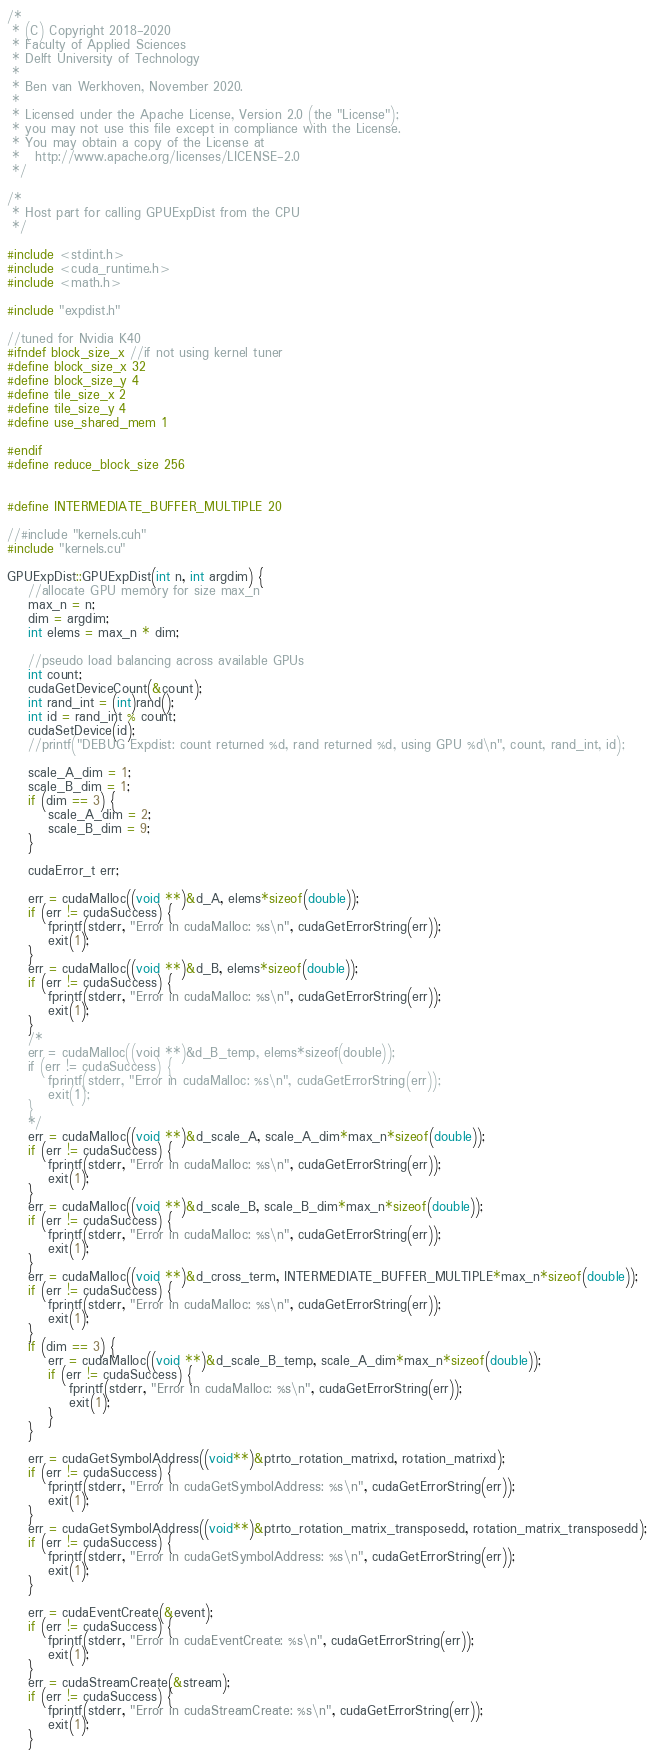Convert code to text. <code><loc_0><loc_0><loc_500><loc_500><_Cuda_>/*
 * (C) Copyright 2018-2020      
 * Faculty of Applied Sciences
 * Delft University of Technology
 *
 * Ben van Werkhoven, November 2020.
 *
 * Licensed under the Apache License, Version 2.0 (the "License");
 * you may not use this file except in compliance with the License.
 * You may obtain a copy of the License at
 *   http://www.apache.org/licenses/LICENSE-2.0
 */
        
/*
 * Host part for calling GPUExpDist from the CPU 
 */

#include <stdint.h>
#include <cuda_runtime.h>
#include <math.h>

#include "expdist.h"

//tuned for Nvidia K40
#ifndef block_size_x //if not using kernel tuner
#define block_size_x 32
#define block_size_y 4
#define tile_size_x 2
#define tile_size_y 4
#define use_shared_mem 1

#endif
#define reduce_block_size 256


#define INTERMEDIATE_BUFFER_MULTIPLE 20

//#include "kernels.cuh"
#include "kernels.cu"

GPUExpDist::GPUExpDist(int n, int argdim) {
    //allocate GPU memory for size max_n
    max_n = n;
    dim = argdim;
    int elems = max_n * dim;

    //pseudo load balancing across available GPUs
    int count;
    cudaGetDeviceCount(&count);
    int rand_int = (int)rand();
    int id = rand_int % count;
    cudaSetDevice(id);
    //printf("DEBUG Expdist: count returned %d, rand returned %d, using GPU %d\n", count, rand_int, id);

    scale_A_dim = 1;
    scale_B_dim = 1;
    if (dim == 3) {
        scale_A_dim = 2;
        scale_B_dim = 9;
    }

    cudaError_t err;

    err = cudaMalloc((void **)&d_A, elems*sizeof(double));
    if (err != cudaSuccess) {
        fprintf(stderr, "Error in cudaMalloc: %s\n", cudaGetErrorString(err));
        exit(1);
    }
    err = cudaMalloc((void **)&d_B, elems*sizeof(double));
    if (err != cudaSuccess) {
        fprintf(stderr, "Error in cudaMalloc: %s\n", cudaGetErrorString(err));
        exit(1);
    }
    /*
    err = cudaMalloc((void **)&d_B_temp, elems*sizeof(double));
    if (err != cudaSuccess) {
        fprintf(stderr, "Error in cudaMalloc: %s\n", cudaGetErrorString(err));
        exit(1);
    }
    */
    err = cudaMalloc((void **)&d_scale_A, scale_A_dim*max_n*sizeof(double));
    if (err != cudaSuccess) {
        fprintf(stderr, "Error in cudaMalloc: %s\n", cudaGetErrorString(err));
        exit(1);
    }
    err = cudaMalloc((void **)&d_scale_B, scale_B_dim*max_n*sizeof(double));
    if (err != cudaSuccess) {
        fprintf(stderr, "Error in cudaMalloc: %s\n", cudaGetErrorString(err));
        exit(1);
    }
    err = cudaMalloc((void **)&d_cross_term, INTERMEDIATE_BUFFER_MULTIPLE*max_n*sizeof(double));
    if (err != cudaSuccess) {
        fprintf(stderr, "Error in cudaMalloc: %s\n", cudaGetErrorString(err));
        exit(1);
    }
    if (dim == 3) {
        err = cudaMalloc((void **)&d_scale_B_temp, scale_A_dim*max_n*sizeof(double));
        if (err != cudaSuccess) {
            fprintf(stderr, "Error in cudaMalloc: %s\n", cudaGetErrorString(err));
            exit(1);
        }
    }

    err = cudaGetSymbolAddress((void**)&ptrto_rotation_matrixd, rotation_matrixd);
    if (err != cudaSuccess) {
        fprintf(stderr, "Error in cudaGetSymbolAddress: %s\n", cudaGetErrorString(err));
        exit(1);
    }
    err = cudaGetSymbolAddress((void**)&ptrto_rotation_matrix_transposedd, rotation_matrix_transposedd);
    if (err != cudaSuccess) {
        fprintf(stderr, "Error in cudaGetSymbolAddress: %s\n", cudaGetErrorString(err));
        exit(1);
    }

    err = cudaEventCreate(&event);
    if (err != cudaSuccess) {
        fprintf(stderr, "Error in cudaEventCreate: %s\n", cudaGetErrorString(err));
        exit(1);
    }
    err = cudaStreamCreate(&stream);
    if (err != cudaSuccess) {
        fprintf(stderr, "Error in cudaStreamCreate: %s\n", cudaGetErrorString(err));
        exit(1);
    }</code> 